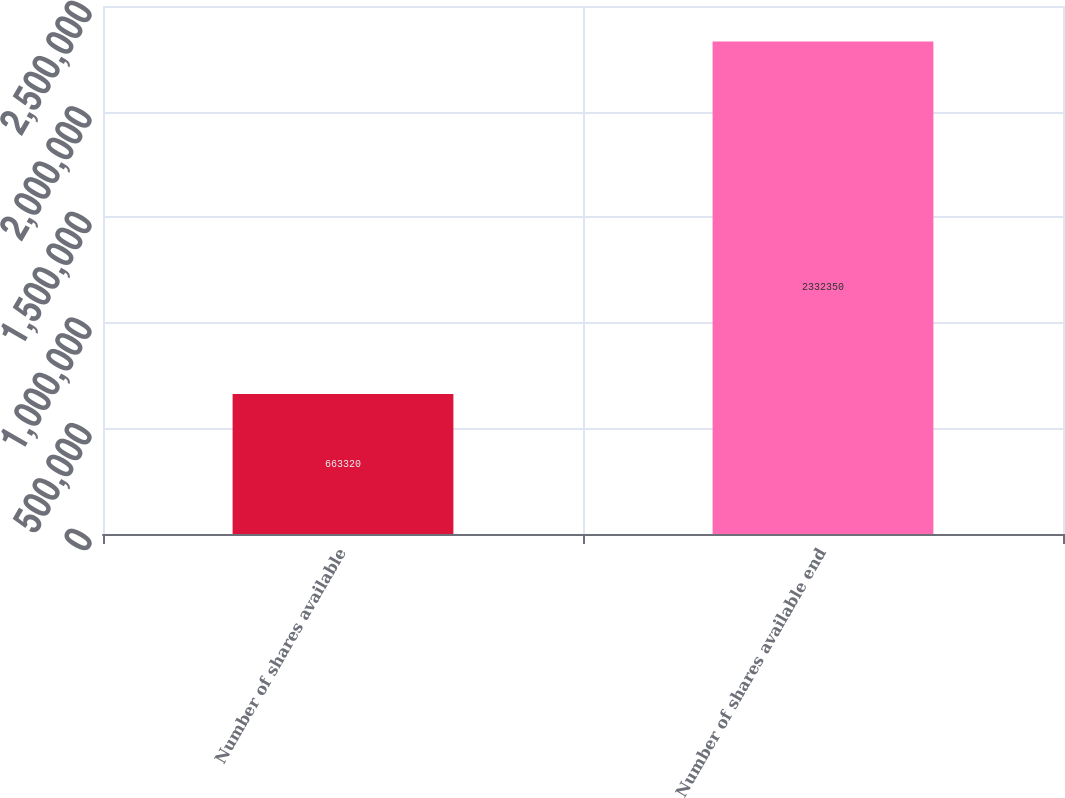Convert chart. <chart><loc_0><loc_0><loc_500><loc_500><bar_chart><fcel>Number of shares available<fcel>Number of shares available end<nl><fcel>663320<fcel>2.33235e+06<nl></chart> 